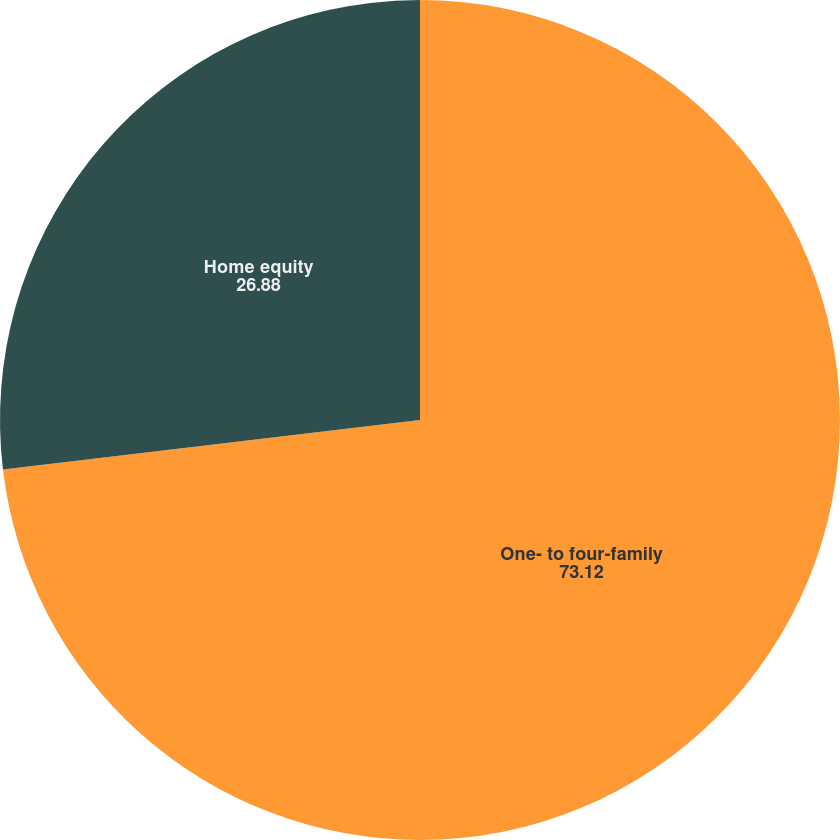Convert chart to OTSL. <chart><loc_0><loc_0><loc_500><loc_500><pie_chart><fcel>One- to four-family<fcel>Home equity<nl><fcel>73.12%<fcel>26.88%<nl></chart> 